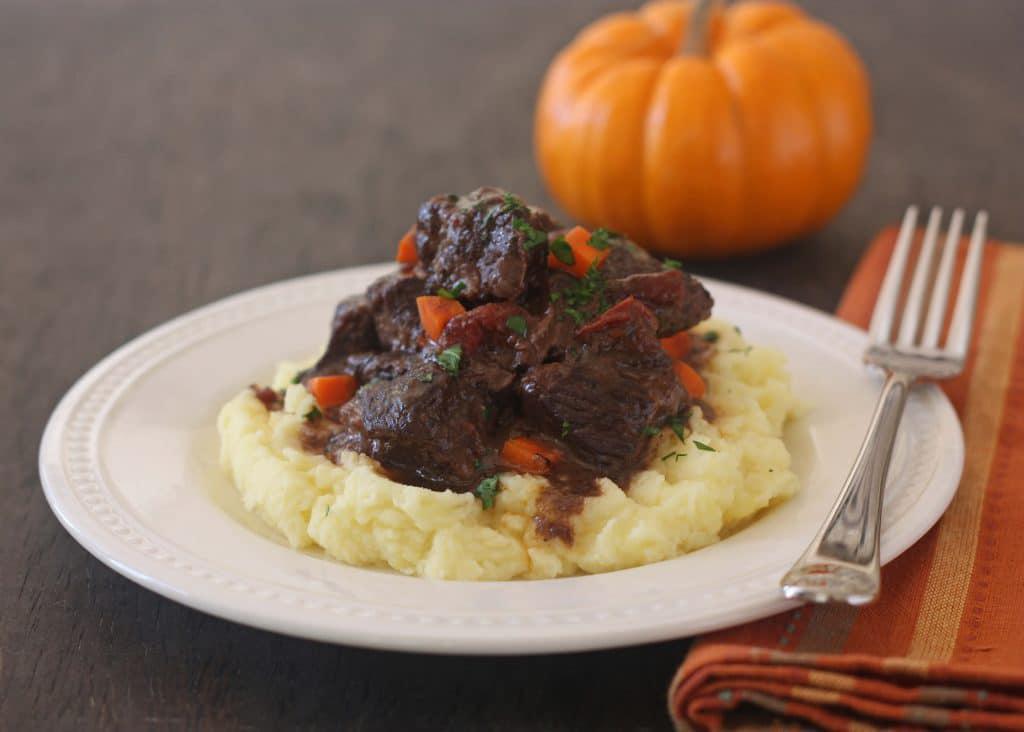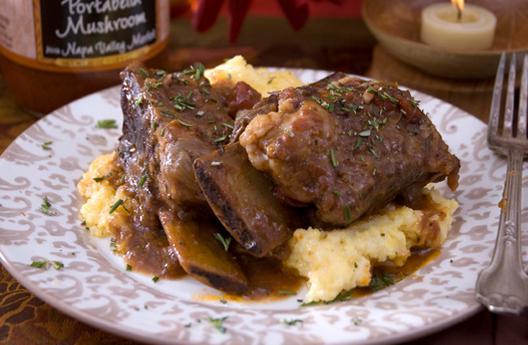The first image is the image on the left, the second image is the image on the right. For the images displayed, is the sentence "there is a visible orange vegetable in the image on the left side." factually correct? Answer yes or no. Yes. The first image is the image on the left, the second image is the image on the right. Considering the images on both sides, is "There are absolutely NO forks present." valid? Answer yes or no. No. 